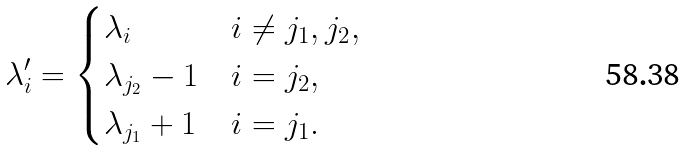Convert formula to latex. <formula><loc_0><loc_0><loc_500><loc_500>\lambda _ { i } ^ { \prime } = \begin{cases} \lambda _ { i } & i \ne j _ { 1 } , j _ { 2 } , \\ \lambda _ { j _ { 2 } } - 1 & i = j _ { 2 } , \\ \lambda _ { j _ { 1 } } + 1 & i = j _ { 1 } . \end{cases}</formula> 